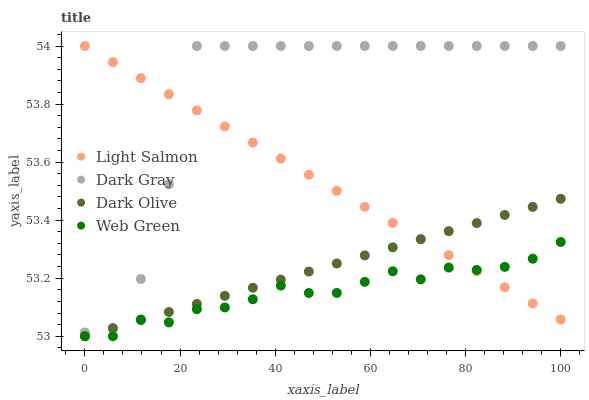Does Web Green have the minimum area under the curve?
Answer yes or no. Yes. Does Dark Gray have the maximum area under the curve?
Answer yes or no. Yes. Does Light Salmon have the minimum area under the curve?
Answer yes or no. No. Does Light Salmon have the maximum area under the curve?
Answer yes or no. No. Is Dark Olive the smoothest?
Answer yes or no. Yes. Is Dark Gray the roughest?
Answer yes or no. Yes. Is Light Salmon the smoothest?
Answer yes or no. No. Is Light Salmon the roughest?
Answer yes or no. No. Does Dark Olive have the lowest value?
Answer yes or no. Yes. Does Light Salmon have the lowest value?
Answer yes or no. No. Does Light Salmon have the highest value?
Answer yes or no. Yes. Does Dark Olive have the highest value?
Answer yes or no. No. Is Web Green less than Dark Gray?
Answer yes or no. Yes. Is Dark Gray greater than Web Green?
Answer yes or no. Yes. Does Dark Gray intersect Dark Olive?
Answer yes or no. Yes. Is Dark Gray less than Dark Olive?
Answer yes or no. No. Is Dark Gray greater than Dark Olive?
Answer yes or no. No. Does Web Green intersect Dark Gray?
Answer yes or no. No. 